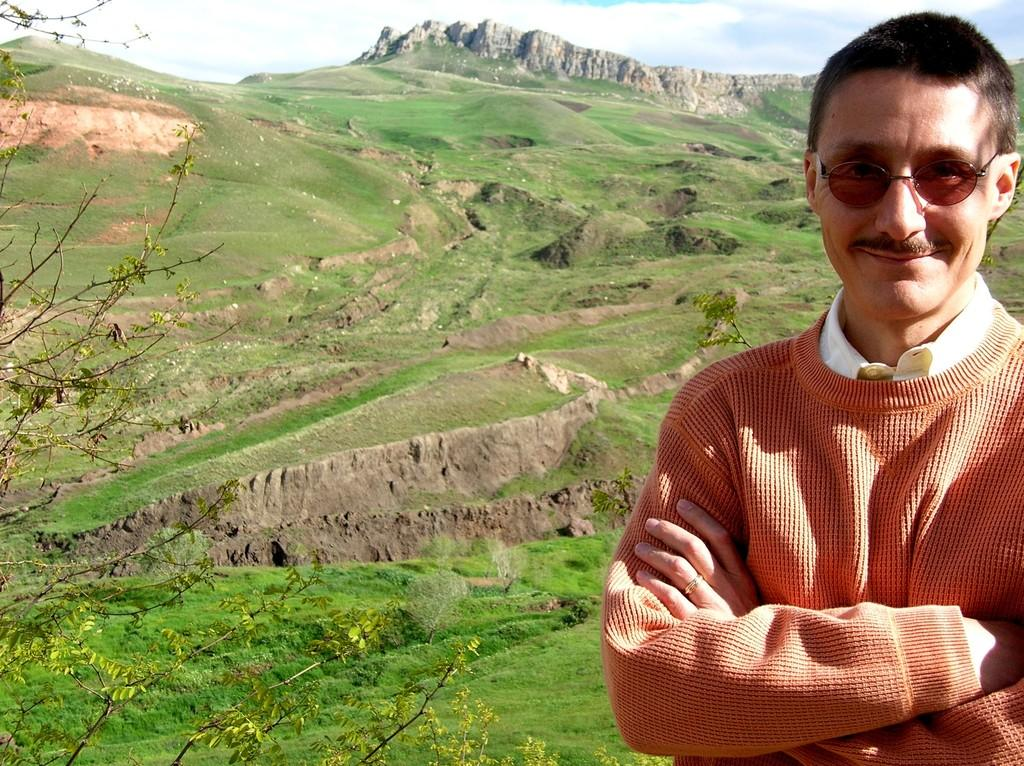What is the main subject of the image? There is a man standing in the image. Can you describe the man's appearance? The man is wearing spectacles. What can be seen in the background of the image? There is a hill in the background of the image. What is the condition of the sky in the image? The sky is blue and cloudy. What type of vegetation is present in the image? Trees are visible in the image, and grass is present on the ground. What type of cable is connected to the faucet in the image? There is no cable or faucet present in the image. What is the size of the man in the image? The size of the man cannot be determined from the image alone, as there is no reference point for comparison. 